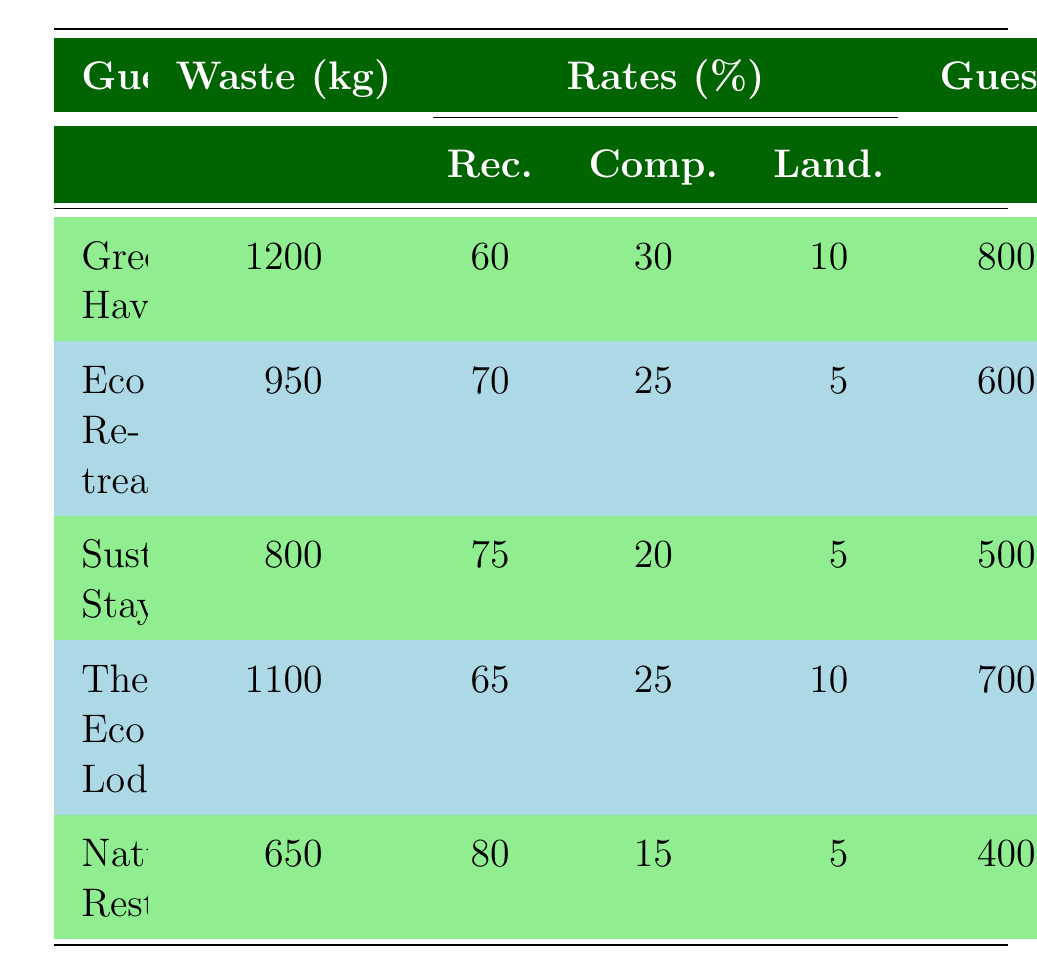What is the total waste generated by all guesthouses? To find the total waste generated, I will sum the waste generated by each guesthouse: 1200 + 950 + 800 + 1100 + 650 = 3750 kg.
Answer: 3750 kg Which guesthouse has the highest composting rate? The composting rates for each guesthouse are: Green Haven (30%), Eco Retreat (25%), Sustainable Stays (20%), The Eco Lodge (25%), and Nature's Rest (15%). The highest composting rate is 30% at Green Haven.
Answer: Green Haven Is the recycling rate of Eco Retreat higher than Nature's Rest? The recycling rates are Eco Retreat (70%) and Nature's Rest (80%). Since 70% is less than 80%, Eco Retreat does not have a higher recycling rate.
Answer: No What is the average waste per guest for Sustainable Stays? To calculate the waste per guest for Sustainable Stays, I divide the total waste generated (800 kg) by the number of guests (500): 800 / 500 = 1.6 kg.
Answer: 1.6 kg Which guesthouse generated the least amount of waste? The waste generated by each guesthouse is: Green Haven (1200 kg), Eco Retreat (950 kg), Sustainable Stays (800 kg), The Eco Lodge (1100 kg), and Nature's Rest (650 kg). The least waste generated is by Nature's Rest.
Answer: Nature's Rest How much organic waste was generated by the Eco Lodge? The organic waste generated by The Eco Lodge is specifically listed as 275 kg in the waste distribution section.
Answer: 275 kg What percentage of total waste from Green Haven is compostable? The compostable waste from Green Haven is 30% of the total waste. Calculation: 30% of 1200 kg = 360 kg is compostable. Thus, the percentage is 30%.
Answer: 30% Which guesthouse has a recycling rate closest to 70%? The guesthouses' recycling rates are: Green Haven (60%), Eco Retreat (70%), Sustainable Stays (75%), The Eco Lodge (65%), and Nature's Rest (80%). Eco Retreat has the exact recycling rate of 70%, which is the closest.
Answer: Eco Retreat 